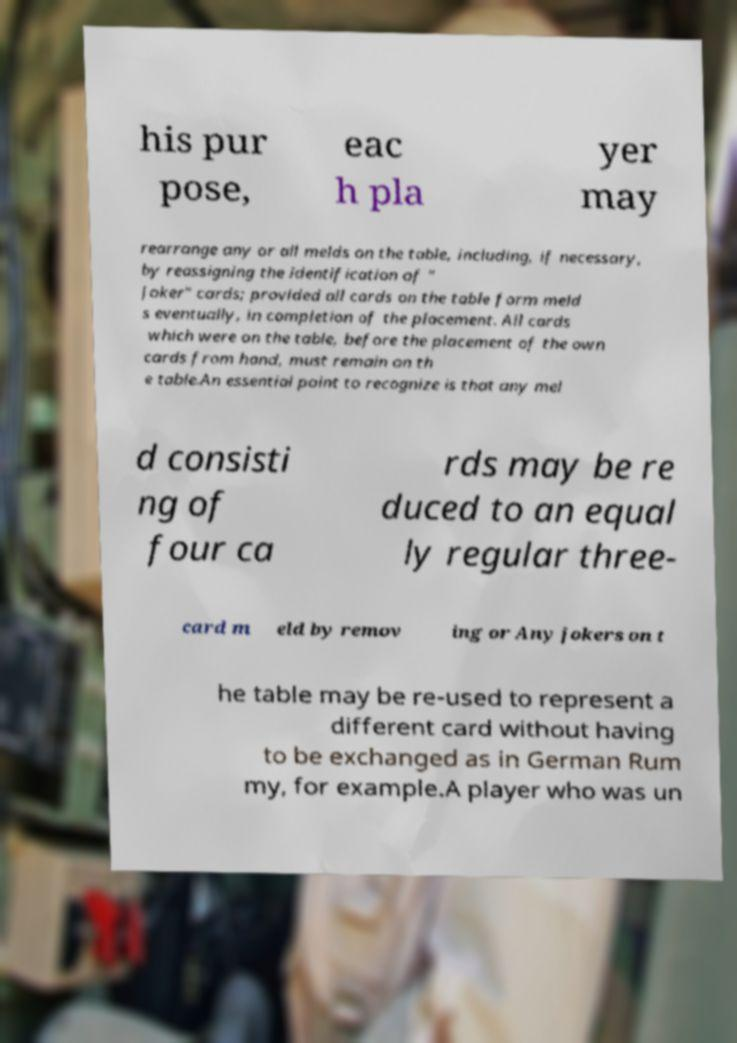Can you read and provide the text displayed in the image?This photo seems to have some interesting text. Can you extract and type it out for me? his pur pose, eac h pla yer may rearrange any or all melds on the table, including, if necessary, by reassigning the identification of " Joker" cards; provided all cards on the table form meld s eventually, in completion of the placement. All cards which were on the table, before the placement of the own cards from hand, must remain on th e table.An essential point to recognize is that any mel d consisti ng of four ca rds may be re duced to an equal ly regular three- card m eld by remov ing or Any jokers on t he table may be re-used to represent a different card without having to be exchanged as in German Rum my, for example.A player who was un 